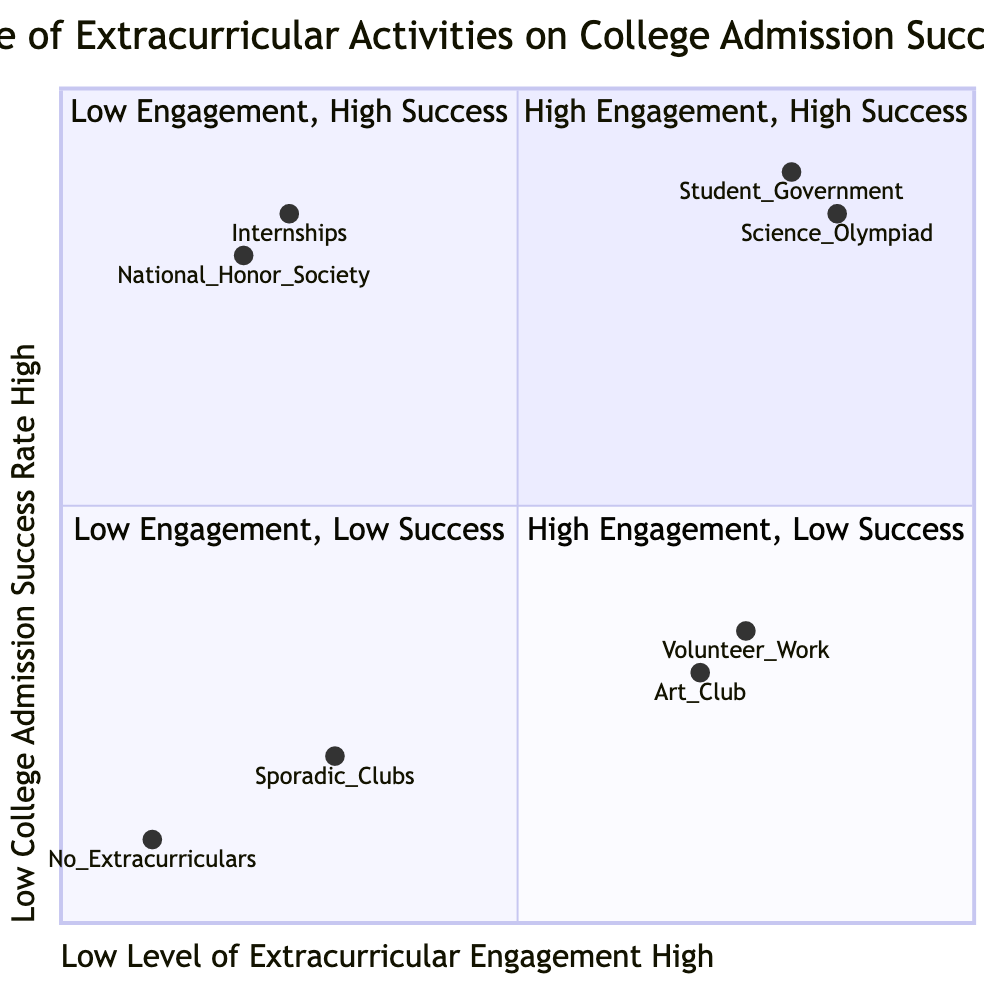What extracurricular activity is in the "High Engagement, High Success" quadrant? The "High Engagement, High Success" quadrant includes examples of Student Government and Science Olympiad, both of which correlate with high college admission success rates.
Answer: Student Government, Science Olympiad Which quadrant has the lowest college admission success rate? The "Low Engagement, Low Success" quadrant represents low involvement in extracurricular activities and is characterized by lower college admission success rates.
Answer: Low Engagement, Low Success How many activities are listed in the "High Engagement, Low Success" quadrant? There are two activities listed in the "High Engagement, Low Success" quadrant: Art Club and Volunteer Work.
Answer: 2 What is the college associated with the National Honor Society in the "Low Engagement, High Success" quadrant? The National Honor Society is associated with Stanford University, demonstrating a high college admission success rate despite minimal participation.
Answer: Stanford University Which quadrant contains both Art Club and Volunteer Work? Art Club and Volunteer Work are found in the "High Engagement, Low Success" quadrant, indicating high involvement but low admission success rates.
Answer: High Engagement, Low Success In what quadrant is "No Extracurriculars" found? The "No Extracurriculars" activity falls into the "Low Engagement, Low Success" quadrant, signifying a lack of extracurricular involvement leading to lower college admission success rates.
Answer: Low Engagement, Low Success Which two colleges are linked to high engagement but low success? Art Club and Volunteer Work are associated with lower success rates, listed in the "High Engagement, Low Success" quadrant alongside these activities' corresponding colleges, which are Community Colleges and Regional State Universities.
Answer: Community Colleges, Regional State Universities What is the main takeaway regarding extracurricular involvement and college admission success? The chart illustrates that high engagement in extracurricular activities generally correlates with higher college admission success rates, contrasting with low engagement leading to lower rates.
Answer: High engagement, higher success What is the college admission rate for internships with minimal participation? Internships, even with minimal participation, are associated with a high college admission success rate, specifically linked to Massachusetts Institute of Technology.
Answer: Massachusetts Institute of Technology 